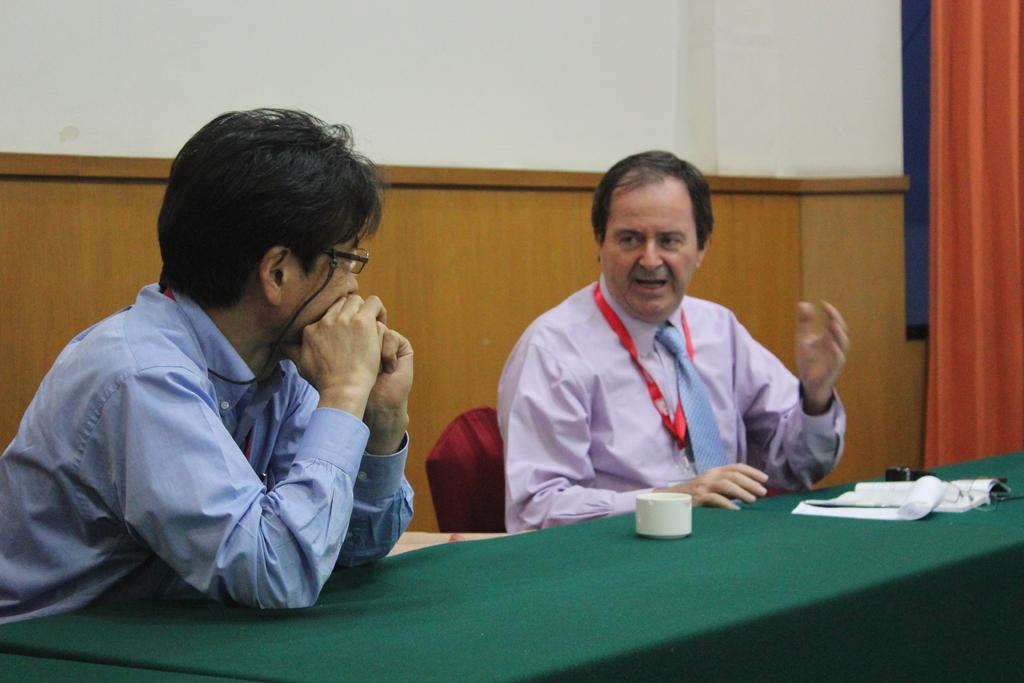How would you summarize this image in a sentence or two? The picture is from a meeting. In the foreground there is a desk, on the desk there is a book, cup. In the center of the image there are two men seated, one in the center is talking. On the right there is a curtain. In the background there is a wall. chair is red. 